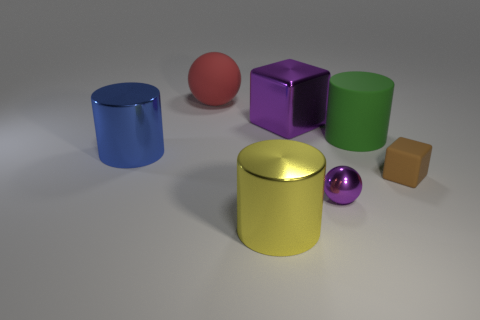Add 1 small purple metallic things. How many objects exist? 8 Subtract all large metal cylinders. How many cylinders are left? 1 Subtract all cyan cylinders. How many cyan balls are left? 0 Subtract all blue cylinders. How many cylinders are left? 2 Subtract all spheres. How many objects are left? 5 Subtract all big yellow metal objects. Subtract all spheres. How many objects are left? 4 Add 4 yellow cylinders. How many yellow cylinders are left? 5 Add 5 cylinders. How many cylinders exist? 8 Subtract 1 blue cylinders. How many objects are left? 6 Subtract all blue cylinders. Subtract all green spheres. How many cylinders are left? 2 